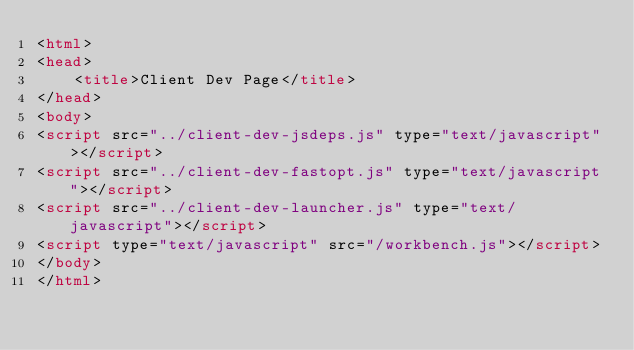<code> <loc_0><loc_0><loc_500><loc_500><_HTML_><html>
<head>
    <title>Client Dev Page</title>
</head>
<body>
<script src="../client-dev-jsdeps.js" type="text/javascript"></script>
<script src="../client-dev-fastopt.js" type="text/javascript"></script>
<script src="../client-dev-launcher.js" type="text/javascript"></script>
<script type="text/javascript" src="/workbench.js"></script>
</body>
</html></code> 